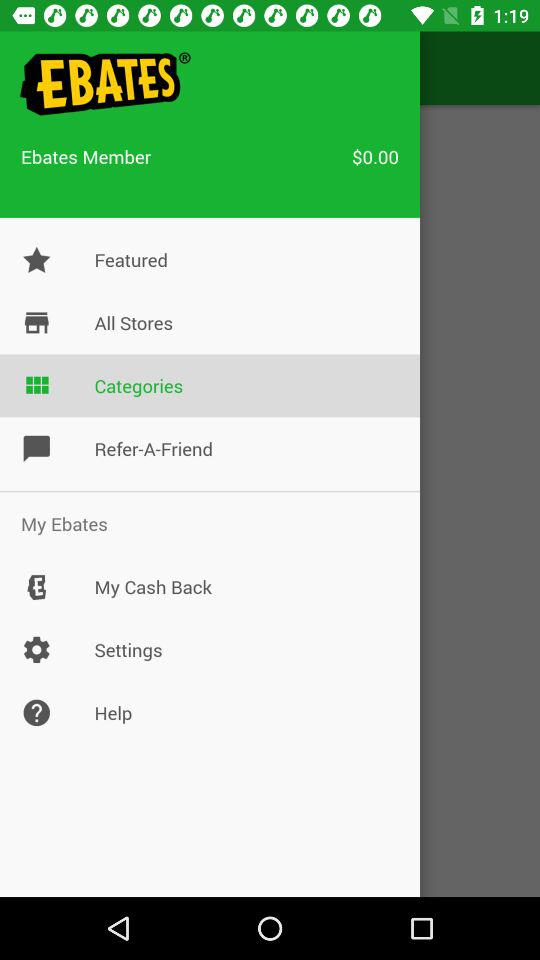What is the name of the application? The name of the application is "EBATES". 